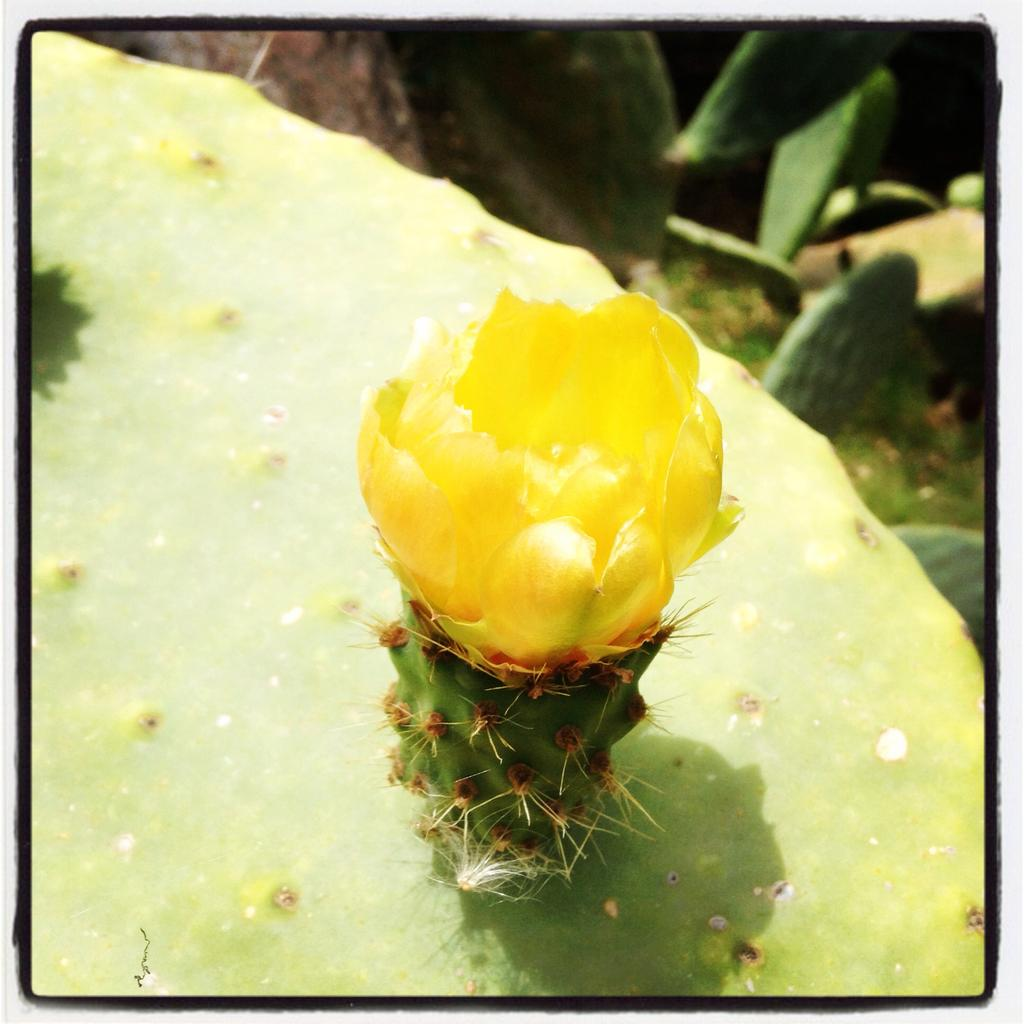What type of plant is the main subject of the image? There is a cactus plant with a yellow flower in the image. Are there any other cactus plants visible in the image? Yes, there are many cactus plants in the background of the image. What advice does the friend give to the grandmother in the image? There is no friend or grandmother present in the image, and therefore no such conversation can be observed. 